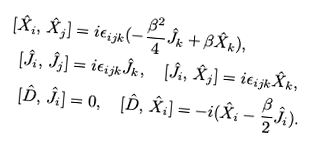<formula> <loc_0><loc_0><loc_500><loc_500>[ \hat { X } _ { i } , \, \hat { X } _ { j } ] & = i \epsilon _ { i j k } ( - \frac { \beta ^ { 2 } } { 4 } \hat { J } _ { k } + \beta \hat { X } _ { k } ) , \\ [ \hat { J } _ { i } , \, \hat { J } _ { j } ] & = i \epsilon _ { i j k } \hat { J } _ { k } , \quad [ \hat { J } _ { i } , \, \hat { X } _ { j } ] = i \epsilon _ { i j k } \hat { X } _ { k } , \\ [ \hat { D } , \, \hat { J } _ { i } ] & = 0 , \quad [ \hat { D } , \, \hat { X } _ { i } ] = - i ( \hat { X } _ { i } - \frac { \beta } { 2 } \hat { J } _ { i } ) .</formula> 